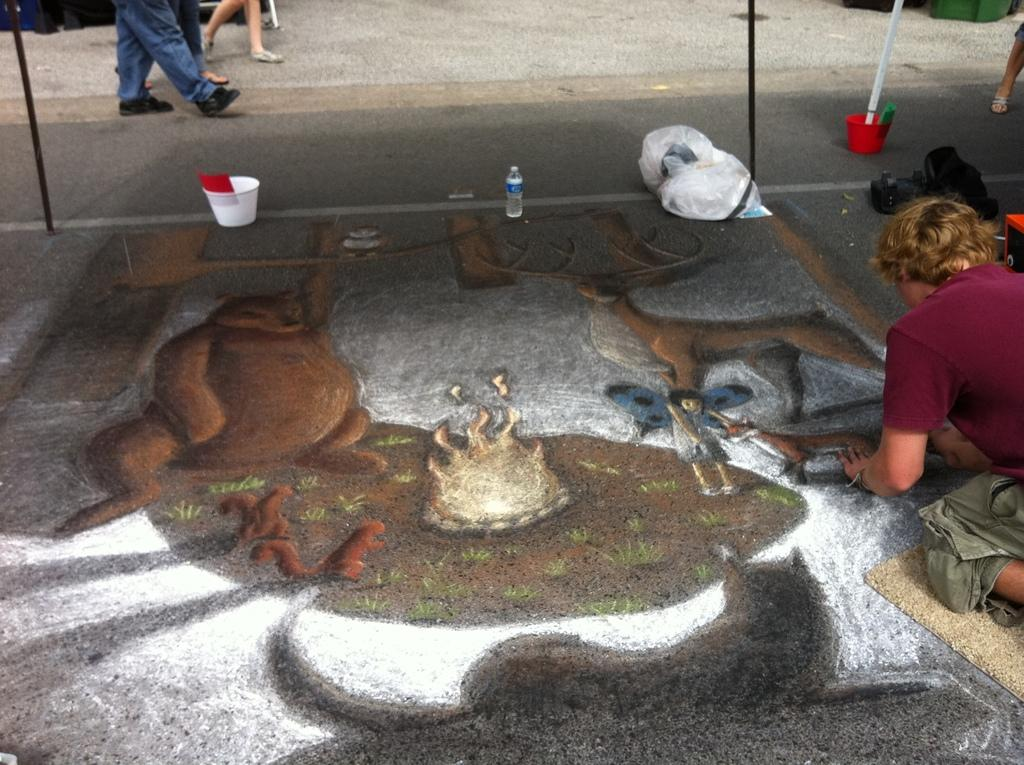Who is in the image? There is a man in the image. What is the man wearing? The man is wearing a maroon t-shirt. What is the man doing in the image? The man is sitting on the ground and making a craft. Where is the man making the craft? The craft is being made on the road. What else can be seen in the image? There is a road visible in the image, and there are people walking on the road in the background. What type of rock is the man using to make the craft in the image? There is no rock visible in the image, and the man is not using any rock to make the craft. 